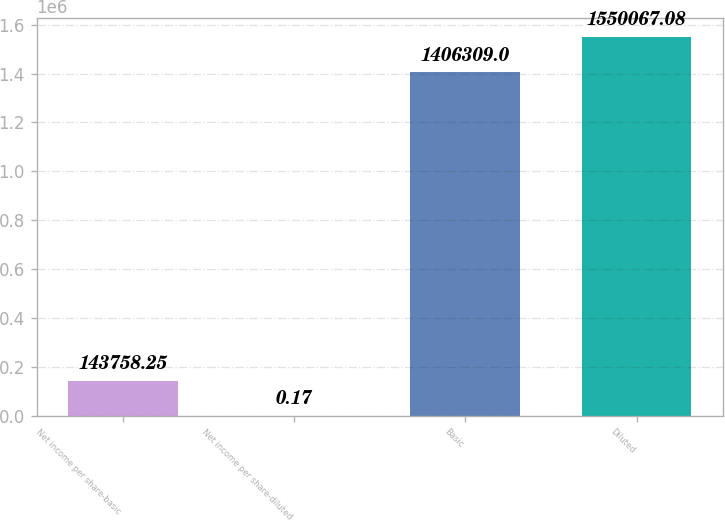Convert chart to OTSL. <chart><loc_0><loc_0><loc_500><loc_500><bar_chart><fcel>Net income per share-basic<fcel>Net income per share-diluted<fcel>Basic<fcel>Diluted<nl><fcel>143758<fcel>0.17<fcel>1.40631e+06<fcel>1.55007e+06<nl></chart> 